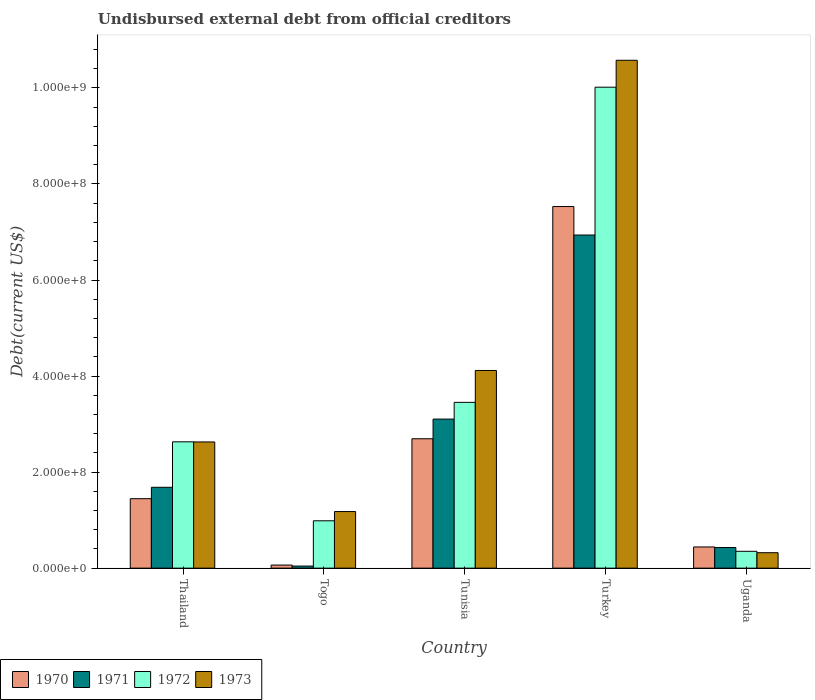How many groups of bars are there?
Your answer should be compact. 5. What is the label of the 3rd group of bars from the left?
Give a very brief answer. Tunisia. What is the total debt in 1972 in Turkey?
Provide a succinct answer. 1.00e+09. Across all countries, what is the maximum total debt in 1970?
Offer a terse response. 7.53e+08. Across all countries, what is the minimum total debt in 1971?
Offer a terse response. 4.34e+06. In which country was the total debt in 1970 maximum?
Offer a terse response. Turkey. In which country was the total debt in 1971 minimum?
Your response must be concise. Togo. What is the total total debt in 1970 in the graph?
Offer a very short reply. 1.22e+09. What is the difference between the total debt in 1970 in Tunisia and that in Uganda?
Ensure brevity in your answer.  2.25e+08. What is the difference between the total debt in 1970 in Thailand and the total debt in 1973 in Tunisia?
Provide a short and direct response. -2.67e+08. What is the average total debt in 1972 per country?
Your answer should be compact. 3.49e+08. What is the difference between the total debt of/in 1970 and total debt of/in 1971 in Uganda?
Offer a very short reply. 1.23e+06. What is the ratio of the total debt in 1973 in Tunisia to that in Turkey?
Give a very brief answer. 0.39. What is the difference between the highest and the second highest total debt in 1972?
Your answer should be very brief. 6.56e+08. What is the difference between the highest and the lowest total debt in 1972?
Offer a terse response. 9.67e+08. In how many countries, is the total debt in 1972 greater than the average total debt in 1972 taken over all countries?
Your answer should be compact. 1. Is it the case that in every country, the sum of the total debt in 1972 and total debt in 1971 is greater than the sum of total debt in 1973 and total debt in 1970?
Offer a terse response. No. What does the 1st bar from the left in Turkey represents?
Ensure brevity in your answer.  1970. What does the 2nd bar from the right in Thailand represents?
Ensure brevity in your answer.  1972. Where does the legend appear in the graph?
Give a very brief answer. Bottom left. How are the legend labels stacked?
Offer a very short reply. Horizontal. What is the title of the graph?
Your response must be concise. Undisbursed external debt from official creditors. What is the label or title of the X-axis?
Offer a very short reply. Country. What is the label or title of the Y-axis?
Offer a very short reply. Debt(current US$). What is the Debt(current US$) in 1970 in Thailand?
Make the answer very short. 1.45e+08. What is the Debt(current US$) of 1971 in Thailand?
Offer a very short reply. 1.68e+08. What is the Debt(current US$) of 1972 in Thailand?
Your answer should be compact. 2.63e+08. What is the Debt(current US$) of 1973 in Thailand?
Provide a succinct answer. 2.63e+08. What is the Debt(current US$) of 1970 in Togo?
Provide a short and direct response. 6.43e+06. What is the Debt(current US$) in 1971 in Togo?
Provide a succinct answer. 4.34e+06. What is the Debt(current US$) in 1972 in Togo?
Offer a terse response. 9.86e+07. What is the Debt(current US$) in 1973 in Togo?
Offer a terse response. 1.18e+08. What is the Debt(current US$) of 1970 in Tunisia?
Provide a succinct answer. 2.69e+08. What is the Debt(current US$) of 1971 in Tunisia?
Provide a succinct answer. 3.10e+08. What is the Debt(current US$) of 1972 in Tunisia?
Your answer should be compact. 3.45e+08. What is the Debt(current US$) in 1973 in Tunisia?
Your answer should be very brief. 4.12e+08. What is the Debt(current US$) in 1970 in Turkey?
Offer a terse response. 7.53e+08. What is the Debt(current US$) in 1971 in Turkey?
Your response must be concise. 6.94e+08. What is the Debt(current US$) of 1972 in Turkey?
Offer a very short reply. 1.00e+09. What is the Debt(current US$) of 1973 in Turkey?
Your answer should be compact. 1.06e+09. What is the Debt(current US$) of 1970 in Uganda?
Give a very brief answer. 4.41e+07. What is the Debt(current US$) in 1971 in Uganda?
Offer a terse response. 4.29e+07. What is the Debt(current US$) in 1972 in Uganda?
Ensure brevity in your answer.  3.51e+07. What is the Debt(current US$) in 1973 in Uganda?
Ensure brevity in your answer.  3.21e+07. Across all countries, what is the maximum Debt(current US$) in 1970?
Keep it short and to the point. 7.53e+08. Across all countries, what is the maximum Debt(current US$) in 1971?
Provide a short and direct response. 6.94e+08. Across all countries, what is the maximum Debt(current US$) in 1972?
Ensure brevity in your answer.  1.00e+09. Across all countries, what is the maximum Debt(current US$) of 1973?
Your response must be concise. 1.06e+09. Across all countries, what is the minimum Debt(current US$) in 1970?
Offer a very short reply. 6.43e+06. Across all countries, what is the minimum Debt(current US$) in 1971?
Your answer should be very brief. 4.34e+06. Across all countries, what is the minimum Debt(current US$) of 1972?
Offer a very short reply. 3.51e+07. Across all countries, what is the minimum Debt(current US$) in 1973?
Provide a succinct answer. 3.21e+07. What is the total Debt(current US$) in 1970 in the graph?
Offer a terse response. 1.22e+09. What is the total Debt(current US$) of 1971 in the graph?
Make the answer very short. 1.22e+09. What is the total Debt(current US$) of 1972 in the graph?
Offer a very short reply. 1.74e+09. What is the total Debt(current US$) in 1973 in the graph?
Your response must be concise. 1.88e+09. What is the difference between the Debt(current US$) of 1970 in Thailand and that in Togo?
Give a very brief answer. 1.38e+08. What is the difference between the Debt(current US$) of 1971 in Thailand and that in Togo?
Keep it short and to the point. 1.64e+08. What is the difference between the Debt(current US$) in 1972 in Thailand and that in Togo?
Keep it short and to the point. 1.64e+08. What is the difference between the Debt(current US$) in 1973 in Thailand and that in Togo?
Your answer should be compact. 1.45e+08. What is the difference between the Debt(current US$) of 1970 in Thailand and that in Tunisia?
Offer a terse response. -1.25e+08. What is the difference between the Debt(current US$) in 1971 in Thailand and that in Tunisia?
Provide a succinct answer. -1.42e+08. What is the difference between the Debt(current US$) in 1972 in Thailand and that in Tunisia?
Your answer should be compact. -8.22e+07. What is the difference between the Debt(current US$) in 1973 in Thailand and that in Tunisia?
Your answer should be compact. -1.49e+08. What is the difference between the Debt(current US$) of 1970 in Thailand and that in Turkey?
Your answer should be compact. -6.08e+08. What is the difference between the Debt(current US$) of 1971 in Thailand and that in Turkey?
Your answer should be compact. -5.25e+08. What is the difference between the Debt(current US$) of 1972 in Thailand and that in Turkey?
Your response must be concise. -7.38e+08. What is the difference between the Debt(current US$) in 1973 in Thailand and that in Turkey?
Ensure brevity in your answer.  -7.95e+08. What is the difference between the Debt(current US$) in 1970 in Thailand and that in Uganda?
Keep it short and to the point. 1.01e+08. What is the difference between the Debt(current US$) in 1971 in Thailand and that in Uganda?
Provide a short and direct response. 1.25e+08. What is the difference between the Debt(current US$) of 1972 in Thailand and that in Uganda?
Ensure brevity in your answer.  2.28e+08. What is the difference between the Debt(current US$) in 1973 in Thailand and that in Uganda?
Offer a very short reply. 2.31e+08. What is the difference between the Debt(current US$) in 1970 in Togo and that in Tunisia?
Give a very brief answer. -2.63e+08. What is the difference between the Debt(current US$) in 1971 in Togo and that in Tunisia?
Offer a terse response. -3.06e+08. What is the difference between the Debt(current US$) in 1972 in Togo and that in Tunisia?
Ensure brevity in your answer.  -2.47e+08. What is the difference between the Debt(current US$) in 1973 in Togo and that in Tunisia?
Keep it short and to the point. -2.94e+08. What is the difference between the Debt(current US$) of 1970 in Togo and that in Turkey?
Give a very brief answer. -7.47e+08. What is the difference between the Debt(current US$) in 1971 in Togo and that in Turkey?
Give a very brief answer. -6.89e+08. What is the difference between the Debt(current US$) in 1972 in Togo and that in Turkey?
Your answer should be very brief. -9.03e+08. What is the difference between the Debt(current US$) of 1973 in Togo and that in Turkey?
Provide a succinct answer. -9.40e+08. What is the difference between the Debt(current US$) in 1970 in Togo and that in Uganda?
Offer a terse response. -3.77e+07. What is the difference between the Debt(current US$) in 1971 in Togo and that in Uganda?
Make the answer very short. -3.86e+07. What is the difference between the Debt(current US$) in 1972 in Togo and that in Uganda?
Offer a terse response. 6.35e+07. What is the difference between the Debt(current US$) of 1973 in Togo and that in Uganda?
Provide a short and direct response. 8.57e+07. What is the difference between the Debt(current US$) in 1970 in Tunisia and that in Turkey?
Offer a terse response. -4.84e+08. What is the difference between the Debt(current US$) of 1971 in Tunisia and that in Turkey?
Keep it short and to the point. -3.83e+08. What is the difference between the Debt(current US$) of 1972 in Tunisia and that in Turkey?
Your answer should be very brief. -6.56e+08. What is the difference between the Debt(current US$) in 1973 in Tunisia and that in Turkey?
Provide a succinct answer. -6.46e+08. What is the difference between the Debt(current US$) of 1970 in Tunisia and that in Uganda?
Offer a terse response. 2.25e+08. What is the difference between the Debt(current US$) in 1971 in Tunisia and that in Uganda?
Provide a short and direct response. 2.68e+08. What is the difference between the Debt(current US$) of 1972 in Tunisia and that in Uganda?
Ensure brevity in your answer.  3.10e+08. What is the difference between the Debt(current US$) in 1973 in Tunisia and that in Uganda?
Your answer should be compact. 3.80e+08. What is the difference between the Debt(current US$) in 1970 in Turkey and that in Uganda?
Ensure brevity in your answer.  7.09e+08. What is the difference between the Debt(current US$) of 1971 in Turkey and that in Uganda?
Offer a very short reply. 6.51e+08. What is the difference between the Debt(current US$) in 1972 in Turkey and that in Uganda?
Keep it short and to the point. 9.67e+08. What is the difference between the Debt(current US$) in 1973 in Turkey and that in Uganda?
Give a very brief answer. 1.03e+09. What is the difference between the Debt(current US$) of 1970 in Thailand and the Debt(current US$) of 1971 in Togo?
Keep it short and to the point. 1.40e+08. What is the difference between the Debt(current US$) in 1970 in Thailand and the Debt(current US$) in 1972 in Togo?
Give a very brief answer. 4.61e+07. What is the difference between the Debt(current US$) of 1970 in Thailand and the Debt(current US$) of 1973 in Togo?
Offer a terse response. 2.68e+07. What is the difference between the Debt(current US$) in 1971 in Thailand and the Debt(current US$) in 1972 in Togo?
Offer a very short reply. 6.98e+07. What is the difference between the Debt(current US$) of 1971 in Thailand and the Debt(current US$) of 1973 in Togo?
Ensure brevity in your answer.  5.05e+07. What is the difference between the Debt(current US$) in 1972 in Thailand and the Debt(current US$) in 1973 in Togo?
Make the answer very short. 1.45e+08. What is the difference between the Debt(current US$) of 1970 in Thailand and the Debt(current US$) of 1971 in Tunisia?
Make the answer very short. -1.66e+08. What is the difference between the Debt(current US$) in 1970 in Thailand and the Debt(current US$) in 1972 in Tunisia?
Provide a short and direct response. -2.01e+08. What is the difference between the Debt(current US$) of 1970 in Thailand and the Debt(current US$) of 1973 in Tunisia?
Your answer should be compact. -2.67e+08. What is the difference between the Debt(current US$) in 1971 in Thailand and the Debt(current US$) in 1972 in Tunisia?
Make the answer very short. -1.77e+08. What is the difference between the Debt(current US$) in 1971 in Thailand and the Debt(current US$) in 1973 in Tunisia?
Offer a very short reply. -2.43e+08. What is the difference between the Debt(current US$) of 1972 in Thailand and the Debt(current US$) of 1973 in Tunisia?
Keep it short and to the point. -1.49e+08. What is the difference between the Debt(current US$) of 1970 in Thailand and the Debt(current US$) of 1971 in Turkey?
Your answer should be compact. -5.49e+08. What is the difference between the Debt(current US$) in 1970 in Thailand and the Debt(current US$) in 1972 in Turkey?
Offer a terse response. -8.57e+08. What is the difference between the Debt(current US$) in 1970 in Thailand and the Debt(current US$) in 1973 in Turkey?
Your answer should be very brief. -9.13e+08. What is the difference between the Debt(current US$) of 1971 in Thailand and the Debt(current US$) of 1972 in Turkey?
Ensure brevity in your answer.  -8.33e+08. What is the difference between the Debt(current US$) of 1971 in Thailand and the Debt(current US$) of 1973 in Turkey?
Provide a short and direct response. -8.89e+08. What is the difference between the Debt(current US$) in 1972 in Thailand and the Debt(current US$) in 1973 in Turkey?
Provide a short and direct response. -7.95e+08. What is the difference between the Debt(current US$) of 1970 in Thailand and the Debt(current US$) of 1971 in Uganda?
Your answer should be compact. 1.02e+08. What is the difference between the Debt(current US$) of 1970 in Thailand and the Debt(current US$) of 1972 in Uganda?
Your response must be concise. 1.10e+08. What is the difference between the Debt(current US$) of 1970 in Thailand and the Debt(current US$) of 1973 in Uganda?
Your response must be concise. 1.13e+08. What is the difference between the Debt(current US$) of 1971 in Thailand and the Debt(current US$) of 1972 in Uganda?
Provide a short and direct response. 1.33e+08. What is the difference between the Debt(current US$) of 1971 in Thailand and the Debt(current US$) of 1973 in Uganda?
Offer a terse response. 1.36e+08. What is the difference between the Debt(current US$) in 1972 in Thailand and the Debt(current US$) in 1973 in Uganda?
Provide a short and direct response. 2.31e+08. What is the difference between the Debt(current US$) of 1970 in Togo and the Debt(current US$) of 1971 in Tunisia?
Offer a terse response. -3.04e+08. What is the difference between the Debt(current US$) in 1970 in Togo and the Debt(current US$) in 1972 in Tunisia?
Your answer should be compact. -3.39e+08. What is the difference between the Debt(current US$) of 1970 in Togo and the Debt(current US$) of 1973 in Tunisia?
Your response must be concise. -4.05e+08. What is the difference between the Debt(current US$) in 1971 in Togo and the Debt(current US$) in 1972 in Tunisia?
Offer a terse response. -3.41e+08. What is the difference between the Debt(current US$) in 1971 in Togo and the Debt(current US$) in 1973 in Tunisia?
Provide a short and direct response. -4.07e+08. What is the difference between the Debt(current US$) in 1972 in Togo and the Debt(current US$) in 1973 in Tunisia?
Your answer should be compact. -3.13e+08. What is the difference between the Debt(current US$) in 1970 in Togo and the Debt(current US$) in 1971 in Turkey?
Make the answer very short. -6.87e+08. What is the difference between the Debt(current US$) in 1970 in Togo and the Debt(current US$) in 1972 in Turkey?
Provide a succinct answer. -9.95e+08. What is the difference between the Debt(current US$) in 1970 in Togo and the Debt(current US$) in 1973 in Turkey?
Make the answer very short. -1.05e+09. What is the difference between the Debt(current US$) in 1971 in Togo and the Debt(current US$) in 1972 in Turkey?
Make the answer very short. -9.97e+08. What is the difference between the Debt(current US$) of 1971 in Togo and the Debt(current US$) of 1973 in Turkey?
Your answer should be compact. -1.05e+09. What is the difference between the Debt(current US$) of 1972 in Togo and the Debt(current US$) of 1973 in Turkey?
Ensure brevity in your answer.  -9.59e+08. What is the difference between the Debt(current US$) in 1970 in Togo and the Debt(current US$) in 1971 in Uganda?
Your answer should be compact. -3.65e+07. What is the difference between the Debt(current US$) of 1970 in Togo and the Debt(current US$) of 1972 in Uganda?
Make the answer very short. -2.86e+07. What is the difference between the Debt(current US$) of 1970 in Togo and the Debt(current US$) of 1973 in Uganda?
Provide a succinct answer. -2.57e+07. What is the difference between the Debt(current US$) of 1971 in Togo and the Debt(current US$) of 1972 in Uganda?
Your answer should be very brief. -3.07e+07. What is the difference between the Debt(current US$) of 1971 in Togo and the Debt(current US$) of 1973 in Uganda?
Ensure brevity in your answer.  -2.78e+07. What is the difference between the Debt(current US$) of 1972 in Togo and the Debt(current US$) of 1973 in Uganda?
Offer a terse response. 6.65e+07. What is the difference between the Debt(current US$) in 1970 in Tunisia and the Debt(current US$) in 1971 in Turkey?
Your answer should be very brief. -4.24e+08. What is the difference between the Debt(current US$) in 1970 in Tunisia and the Debt(current US$) in 1972 in Turkey?
Keep it short and to the point. -7.32e+08. What is the difference between the Debt(current US$) of 1970 in Tunisia and the Debt(current US$) of 1973 in Turkey?
Your response must be concise. -7.88e+08. What is the difference between the Debt(current US$) of 1971 in Tunisia and the Debt(current US$) of 1972 in Turkey?
Offer a terse response. -6.91e+08. What is the difference between the Debt(current US$) in 1971 in Tunisia and the Debt(current US$) in 1973 in Turkey?
Keep it short and to the point. -7.47e+08. What is the difference between the Debt(current US$) in 1972 in Tunisia and the Debt(current US$) in 1973 in Turkey?
Make the answer very short. -7.12e+08. What is the difference between the Debt(current US$) in 1970 in Tunisia and the Debt(current US$) in 1971 in Uganda?
Offer a terse response. 2.27e+08. What is the difference between the Debt(current US$) of 1970 in Tunisia and the Debt(current US$) of 1972 in Uganda?
Give a very brief answer. 2.34e+08. What is the difference between the Debt(current US$) of 1970 in Tunisia and the Debt(current US$) of 1973 in Uganda?
Ensure brevity in your answer.  2.37e+08. What is the difference between the Debt(current US$) of 1971 in Tunisia and the Debt(current US$) of 1972 in Uganda?
Offer a terse response. 2.75e+08. What is the difference between the Debt(current US$) in 1971 in Tunisia and the Debt(current US$) in 1973 in Uganda?
Offer a terse response. 2.78e+08. What is the difference between the Debt(current US$) in 1972 in Tunisia and the Debt(current US$) in 1973 in Uganda?
Provide a short and direct response. 3.13e+08. What is the difference between the Debt(current US$) in 1970 in Turkey and the Debt(current US$) in 1971 in Uganda?
Offer a terse response. 7.10e+08. What is the difference between the Debt(current US$) in 1970 in Turkey and the Debt(current US$) in 1972 in Uganda?
Your response must be concise. 7.18e+08. What is the difference between the Debt(current US$) in 1970 in Turkey and the Debt(current US$) in 1973 in Uganda?
Ensure brevity in your answer.  7.21e+08. What is the difference between the Debt(current US$) of 1971 in Turkey and the Debt(current US$) of 1972 in Uganda?
Give a very brief answer. 6.59e+08. What is the difference between the Debt(current US$) in 1971 in Turkey and the Debt(current US$) in 1973 in Uganda?
Make the answer very short. 6.62e+08. What is the difference between the Debt(current US$) in 1972 in Turkey and the Debt(current US$) in 1973 in Uganda?
Offer a very short reply. 9.69e+08. What is the average Debt(current US$) in 1970 per country?
Give a very brief answer. 2.44e+08. What is the average Debt(current US$) of 1971 per country?
Ensure brevity in your answer.  2.44e+08. What is the average Debt(current US$) of 1972 per country?
Offer a terse response. 3.49e+08. What is the average Debt(current US$) of 1973 per country?
Your response must be concise. 3.76e+08. What is the difference between the Debt(current US$) of 1970 and Debt(current US$) of 1971 in Thailand?
Make the answer very short. -2.37e+07. What is the difference between the Debt(current US$) of 1970 and Debt(current US$) of 1972 in Thailand?
Provide a succinct answer. -1.18e+08. What is the difference between the Debt(current US$) in 1970 and Debt(current US$) in 1973 in Thailand?
Give a very brief answer. -1.18e+08. What is the difference between the Debt(current US$) in 1971 and Debt(current US$) in 1972 in Thailand?
Your response must be concise. -9.47e+07. What is the difference between the Debt(current US$) in 1971 and Debt(current US$) in 1973 in Thailand?
Provide a succinct answer. -9.44e+07. What is the difference between the Debt(current US$) in 1970 and Debt(current US$) in 1971 in Togo?
Your answer should be compact. 2.09e+06. What is the difference between the Debt(current US$) of 1970 and Debt(current US$) of 1972 in Togo?
Offer a very short reply. -9.22e+07. What is the difference between the Debt(current US$) of 1970 and Debt(current US$) of 1973 in Togo?
Ensure brevity in your answer.  -1.11e+08. What is the difference between the Debt(current US$) in 1971 and Debt(current US$) in 1972 in Togo?
Offer a very short reply. -9.43e+07. What is the difference between the Debt(current US$) in 1971 and Debt(current US$) in 1973 in Togo?
Offer a very short reply. -1.14e+08. What is the difference between the Debt(current US$) in 1972 and Debt(current US$) in 1973 in Togo?
Make the answer very short. -1.93e+07. What is the difference between the Debt(current US$) in 1970 and Debt(current US$) in 1971 in Tunisia?
Provide a short and direct response. -4.10e+07. What is the difference between the Debt(current US$) in 1970 and Debt(current US$) in 1972 in Tunisia?
Offer a terse response. -7.58e+07. What is the difference between the Debt(current US$) in 1970 and Debt(current US$) in 1973 in Tunisia?
Keep it short and to the point. -1.42e+08. What is the difference between the Debt(current US$) in 1971 and Debt(current US$) in 1972 in Tunisia?
Provide a short and direct response. -3.49e+07. What is the difference between the Debt(current US$) in 1971 and Debt(current US$) in 1973 in Tunisia?
Make the answer very short. -1.01e+08. What is the difference between the Debt(current US$) in 1972 and Debt(current US$) in 1973 in Tunisia?
Ensure brevity in your answer.  -6.64e+07. What is the difference between the Debt(current US$) of 1970 and Debt(current US$) of 1971 in Turkey?
Your answer should be very brief. 5.93e+07. What is the difference between the Debt(current US$) of 1970 and Debt(current US$) of 1972 in Turkey?
Keep it short and to the point. -2.49e+08. What is the difference between the Debt(current US$) of 1970 and Debt(current US$) of 1973 in Turkey?
Provide a succinct answer. -3.05e+08. What is the difference between the Debt(current US$) of 1971 and Debt(current US$) of 1972 in Turkey?
Keep it short and to the point. -3.08e+08. What is the difference between the Debt(current US$) in 1971 and Debt(current US$) in 1973 in Turkey?
Provide a short and direct response. -3.64e+08. What is the difference between the Debt(current US$) of 1972 and Debt(current US$) of 1973 in Turkey?
Provide a short and direct response. -5.61e+07. What is the difference between the Debt(current US$) in 1970 and Debt(current US$) in 1971 in Uganda?
Provide a short and direct response. 1.23e+06. What is the difference between the Debt(current US$) in 1970 and Debt(current US$) in 1972 in Uganda?
Keep it short and to the point. 9.07e+06. What is the difference between the Debt(current US$) of 1970 and Debt(current US$) of 1973 in Uganda?
Offer a terse response. 1.20e+07. What is the difference between the Debt(current US$) of 1971 and Debt(current US$) of 1972 in Uganda?
Give a very brief answer. 7.84e+06. What is the difference between the Debt(current US$) in 1971 and Debt(current US$) in 1973 in Uganda?
Provide a short and direct response. 1.08e+07. What is the difference between the Debt(current US$) in 1972 and Debt(current US$) in 1973 in Uganda?
Your answer should be very brief. 2.93e+06. What is the ratio of the Debt(current US$) in 1970 in Thailand to that in Togo?
Your response must be concise. 22.51. What is the ratio of the Debt(current US$) in 1971 in Thailand to that in Togo?
Provide a succinct answer. 38.84. What is the ratio of the Debt(current US$) in 1972 in Thailand to that in Togo?
Provide a short and direct response. 2.67. What is the ratio of the Debt(current US$) in 1973 in Thailand to that in Togo?
Make the answer very short. 2.23. What is the ratio of the Debt(current US$) of 1970 in Thailand to that in Tunisia?
Provide a short and direct response. 0.54. What is the ratio of the Debt(current US$) of 1971 in Thailand to that in Tunisia?
Provide a succinct answer. 0.54. What is the ratio of the Debt(current US$) in 1972 in Thailand to that in Tunisia?
Ensure brevity in your answer.  0.76. What is the ratio of the Debt(current US$) of 1973 in Thailand to that in Tunisia?
Ensure brevity in your answer.  0.64. What is the ratio of the Debt(current US$) of 1970 in Thailand to that in Turkey?
Make the answer very short. 0.19. What is the ratio of the Debt(current US$) of 1971 in Thailand to that in Turkey?
Your answer should be very brief. 0.24. What is the ratio of the Debt(current US$) of 1972 in Thailand to that in Turkey?
Provide a short and direct response. 0.26. What is the ratio of the Debt(current US$) of 1973 in Thailand to that in Turkey?
Your response must be concise. 0.25. What is the ratio of the Debt(current US$) in 1970 in Thailand to that in Uganda?
Keep it short and to the point. 3.28. What is the ratio of the Debt(current US$) of 1971 in Thailand to that in Uganda?
Your response must be concise. 3.92. What is the ratio of the Debt(current US$) of 1972 in Thailand to that in Uganda?
Your answer should be compact. 7.5. What is the ratio of the Debt(current US$) in 1973 in Thailand to that in Uganda?
Ensure brevity in your answer.  8.18. What is the ratio of the Debt(current US$) in 1970 in Togo to that in Tunisia?
Make the answer very short. 0.02. What is the ratio of the Debt(current US$) in 1971 in Togo to that in Tunisia?
Offer a terse response. 0.01. What is the ratio of the Debt(current US$) in 1972 in Togo to that in Tunisia?
Give a very brief answer. 0.29. What is the ratio of the Debt(current US$) in 1973 in Togo to that in Tunisia?
Your response must be concise. 0.29. What is the ratio of the Debt(current US$) of 1970 in Togo to that in Turkey?
Keep it short and to the point. 0.01. What is the ratio of the Debt(current US$) of 1971 in Togo to that in Turkey?
Your answer should be very brief. 0.01. What is the ratio of the Debt(current US$) in 1972 in Togo to that in Turkey?
Offer a very short reply. 0.1. What is the ratio of the Debt(current US$) in 1973 in Togo to that in Turkey?
Provide a succinct answer. 0.11. What is the ratio of the Debt(current US$) of 1970 in Togo to that in Uganda?
Provide a short and direct response. 0.15. What is the ratio of the Debt(current US$) in 1971 in Togo to that in Uganda?
Your answer should be compact. 0.1. What is the ratio of the Debt(current US$) of 1972 in Togo to that in Uganda?
Offer a very short reply. 2.81. What is the ratio of the Debt(current US$) in 1973 in Togo to that in Uganda?
Provide a short and direct response. 3.67. What is the ratio of the Debt(current US$) in 1970 in Tunisia to that in Turkey?
Provide a short and direct response. 0.36. What is the ratio of the Debt(current US$) of 1971 in Tunisia to that in Turkey?
Your answer should be compact. 0.45. What is the ratio of the Debt(current US$) in 1972 in Tunisia to that in Turkey?
Ensure brevity in your answer.  0.34. What is the ratio of the Debt(current US$) of 1973 in Tunisia to that in Turkey?
Offer a terse response. 0.39. What is the ratio of the Debt(current US$) of 1970 in Tunisia to that in Uganda?
Offer a very short reply. 6.1. What is the ratio of the Debt(current US$) in 1971 in Tunisia to that in Uganda?
Offer a very short reply. 7.23. What is the ratio of the Debt(current US$) of 1972 in Tunisia to that in Uganda?
Your response must be concise. 9.84. What is the ratio of the Debt(current US$) in 1973 in Tunisia to that in Uganda?
Offer a very short reply. 12.81. What is the ratio of the Debt(current US$) in 1970 in Turkey to that in Uganda?
Make the answer very short. 17.06. What is the ratio of the Debt(current US$) in 1971 in Turkey to that in Uganda?
Offer a terse response. 16.17. What is the ratio of the Debt(current US$) in 1972 in Turkey to that in Uganda?
Provide a succinct answer. 28.56. What is the ratio of the Debt(current US$) of 1973 in Turkey to that in Uganda?
Your answer should be compact. 32.9. What is the difference between the highest and the second highest Debt(current US$) of 1970?
Provide a short and direct response. 4.84e+08. What is the difference between the highest and the second highest Debt(current US$) in 1971?
Ensure brevity in your answer.  3.83e+08. What is the difference between the highest and the second highest Debt(current US$) of 1972?
Ensure brevity in your answer.  6.56e+08. What is the difference between the highest and the second highest Debt(current US$) in 1973?
Provide a short and direct response. 6.46e+08. What is the difference between the highest and the lowest Debt(current US$) in 1970?
Your answer should be compact. 7.47e+08. What is the difference between the highest and the lowest Debt(current US$) in 1971?
Offer a very short reply. 6.89e+08. What is the difference between the highest and the lowest Debt(current US$) in 1972?
Your answer should be very brief. 9.67e+08. What is the difference between the highest and the lowest Debt(current US$) of 1973?
Give a very brief answer. 1.03e+09. 